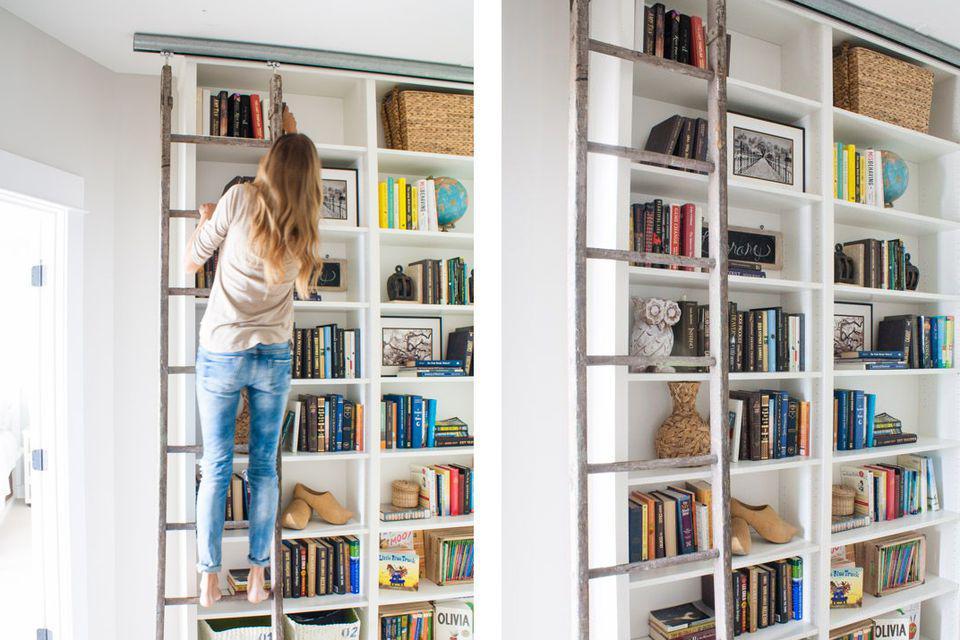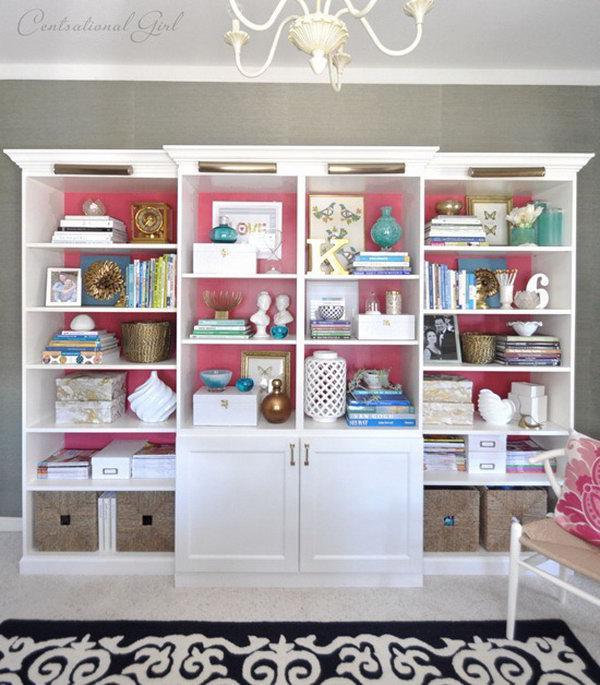The first image is the image on the left, the second image is the image on the right. For the images shown, is this caption "The white bookshelves in one image are floor to ceiling and have a sliding ladder with visible track to allow access to upper shelves." true? Answer yes or no. Yes. The first image is the image on the left, the second image is the image on the right. Evaluate the accuracy of this statement regarding the images: "An image features a woman in jeans in front of a white bookcase.". Is it true? Answer yes or no. Yes. 